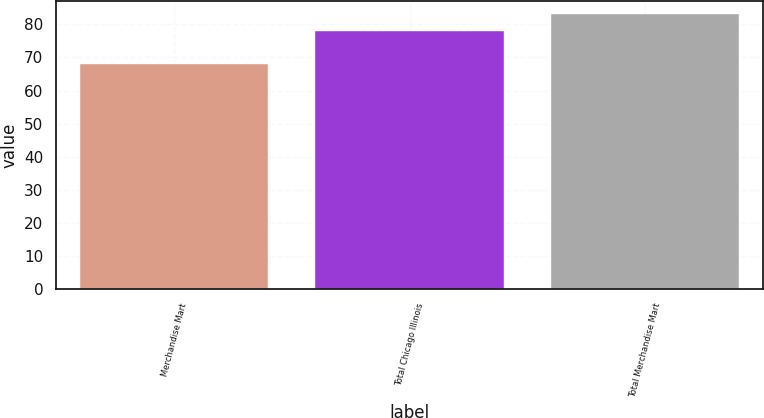Convert chart. <chart><loc_0><loc_0><loc_500><loc_500><bar_chart><fcel>Merchandise Mart<fcel>Total Chicago Illinois<fcel>Total Merchandise Mart<nl><fcel>68<fcel>78<fcel>83<nl></chart> 